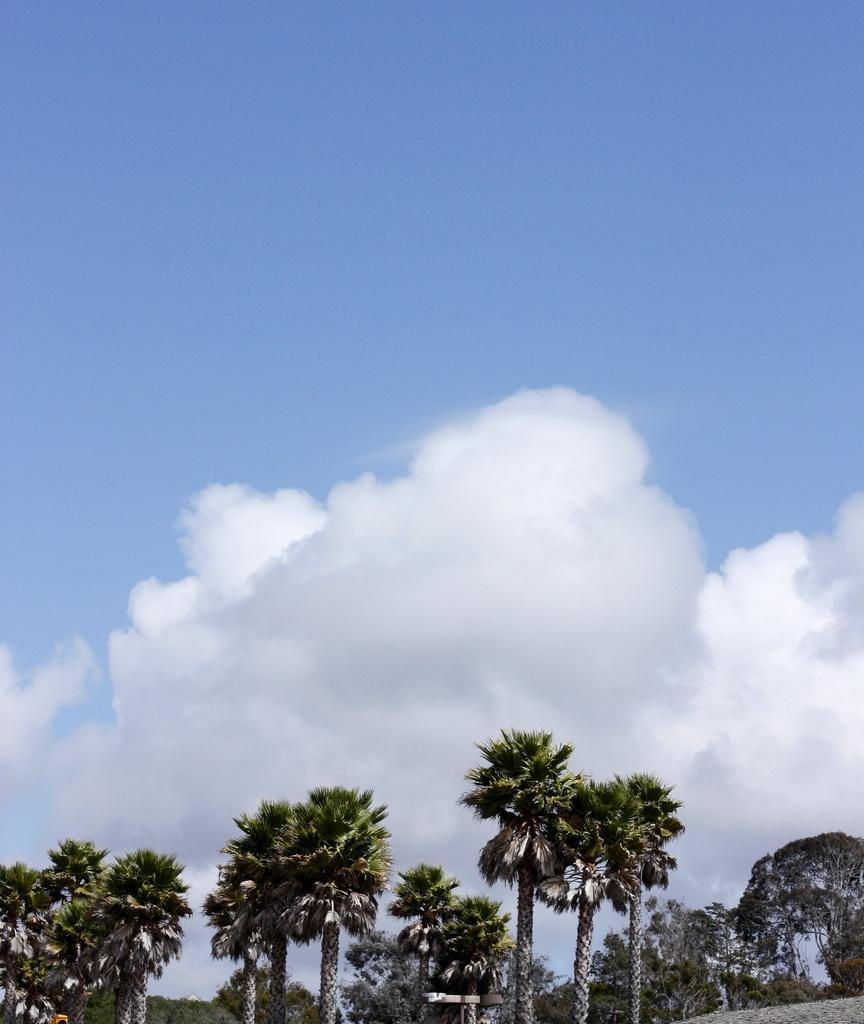What is the primary feature of the landscape in the image? There are many trees in the image. How would you describe the sky in the image? The sky is blue and cloudy in the image. How many tomatoes can be seen hanging from the trees in the image? There are no tomatoes present in the image; it features trees without any visible fruits. What angle do the trees form in the image? The angle of the trees cannot be determined from the image, as it only provides a two-dimensional representation. 